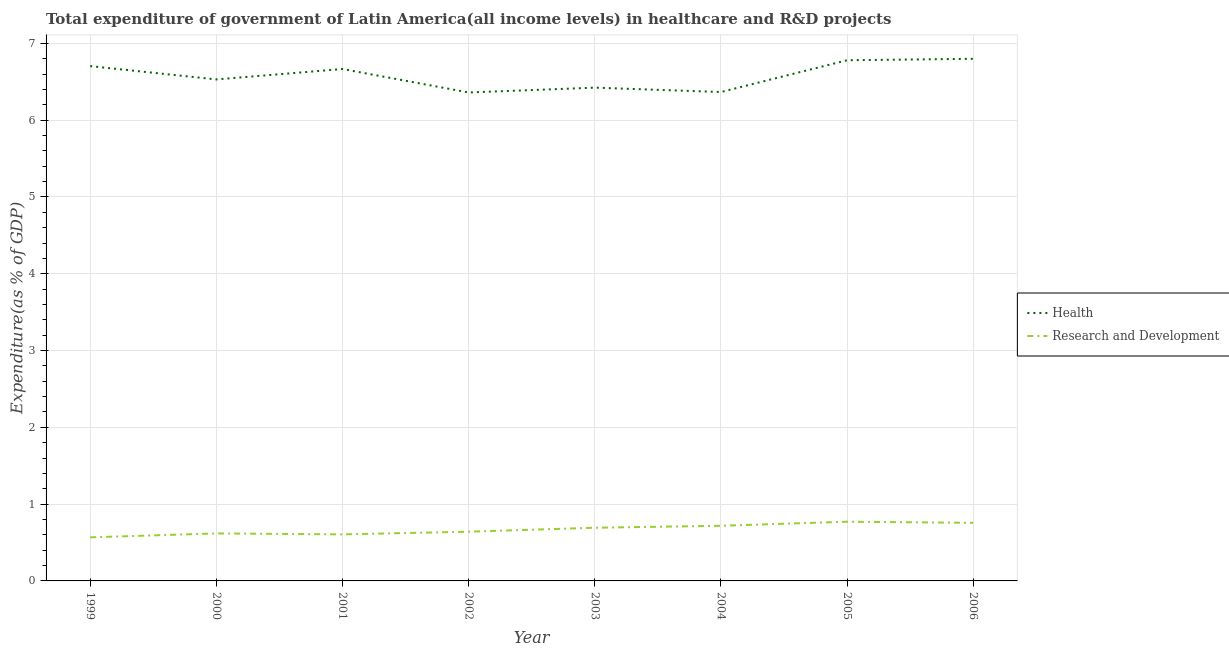What is the expenditure in r&d in 2001?
Provide a short and direct response. 0.61. Across all years, what is the maximum expenditure in r&d?
Provide a succinct answer. 0.77. Across all years, what is the minimum expenditure in healthcare?
Offer a very short reply. 6.36. In which year was the expenditure in r&d minimum?
Your answer should be very brief. 1999. What is the total expenditure in healthcare in the graph?
Your answer should be compact. 52.63. What is the difference between the expenditure in healthcare in 2000 and that in 2003?
Provide a succinct answer. 0.11. What is the difference between the expenditure in r&d in 2006 and the expenditure in healthcare in 2001?
Offer a terse response. -5.91. What is the average expenditure in r&d per year?
Your answer should be very brief. 0.67. In the year 2006, what is the difference between the expenditure in r&d and expenditure in healthcare?
Offer a terse response. -6.04. In how many years, is the expenditure in r&d greater than 0.8 %?
Keep it short and to the point. 0. What is the ratio of the expenditure in healthcare in 1999 to that in 2002?
Offer a terse response. 1.05. What is the difference between the highest and the second highest expenditure in r&d?
Your answer should be very brief. 0.01. What is the difference between the highest and the lowest expenditure in r&d?
Provide a short and direct response. 0.2. In how many years, is the expenditure in healthcare greater than the average expenditure in healthcare taken over all years?
Your response must be concise. 4. Are the values on the major ticks of Y-axis written in scientific E-notation?
Ensure brevity in your answer.  No. Does the graph contain grids?
Provide a short and direct response. Yes. How many legend labels are there?
Your answer should be very brief. 2. What is the title of the graph?
Offer a very short reply. Total expenditure of government of Latin America(all income levels) in healthcare and R&D projects. What is the label or title of the X-axis?
Offer a terse response. Year. What is the label or title of the Y-axis?
Provide a short and direct response. Expenditure(as % of GDP). What is the Expenditure(as % of GDP) in Health in 1999?
Your response must be concise. 6.7. What is the Expenditure(as % of GDP) of Research and Development in 1999?
Give a very brief answer. 0.57. What is the Expenditure(as % of GDP) of Health in 2000?
Make the answer very short. 6.53. What is the Expenditure(as % of GDP) of Research and Development in 2000?
Ensure brevity in your answer.  0.62. What is the Expenditure(as % of GDP) of Health in 2001?
Provide a short and direct response. 6.67. What is the Expenditure(as % of GDP) of Research and Development in 2001?
Your response must be concise. 0.61. What is the Expenditure(as % of GDP) of Health in 2002?
Make the answer very short. 6.36. What is the Expenditure(as % of GDP) of Research and Development in 2002?
Offer a terse response. 0.64. What is the Expenditure(as % of GDP) of Health in 2003?
Keep it short and to the point. 6.42. What is the Expenditure(as % of GDP) in Research and Development in 2003?
Your response must be concise. 0.69. What is the Expenditure(as % of GDP) in Health in 2004?
Give a very brief answer. 6.37. What is the Expenditure(as % of GDP) of Research and Development in 2004?
Provide a short and direct response. 0.72. What is the Expenditure(as % of GDP) in Health in 2005?
Ensure brevity in your answer.  6.78. What is the Expenditure(as % of GDP) of Research and Development in 2005?
Your response must be concise. 0.77. What is the Expenditure(as % of GDP) of Health in 2006?
Provide a short and direct response. 6.8. What is the Expenditure(as % of GDP) of Research and Development in 2006?
Provide a succinct answer. 0.76. Across all years, what is the maximum Expenditure(as % of GDP) in Health?
Keep it short and to the point. 6.8. Across all years, what is the maximum Expenditure(as % of GDP) in Research and Development?
Your answer should be compact. 0.77. Across all years, what is the minimum Expenditure(as % of GDP) of Health?
Give a very brief answer. 6.36. Across all years, what is the minimum Expenditure(as % of GDP) of Research and Development?
Keep it short and to the point. 0.57. What is the total Expenditure(as % of GDP) in Health in the graph?
Make the answer very short. 52.63. What is the total Expenditure(as % of GDP) in Research and Development in the graph?
Offer a very short reply. 5.37. What is the difference between the Expenditure(as % of GDP) of Health in 1999 and that in 2000?
Offer a very short reply. 0.17. What is the difference between the Expenditure(as % of GDP) of Research and Development in 1999 and that in 2000?
Your answer should be compact. -0.05. What is the difference between the Expenditure(as % of GDP) in Health in 1999 and that in 2001?
Provide a short and direct response. 0.04. What is the difference between the Expenditure(as % of GDP) in Research and Development in 1999 and that in 2001?
Your response must be concise. -0.04. What is the difference between the Expenditure(as % of GDP) in Health in 1999 and that in 2002?
Offer a terse response. 0.34. What is the difference between the Expenditure(as % of GDP) in Research and Development in 1999 and that in 2002?
Offer a terse response. -0.07. What is the difference between the Expenditure(as % of GDP) of Health in 1999 and that in 2003?
Keep it short and to the point. 0.28. What is the difference between the Expenditure(as % of GDP) in Research and Development in 1999 and that in 2003?
Your answer should be compact. -0.13. What is the difference between the Expenditure(as % of GDP) of Health in 1999 and that in 2004?
Offer a terse response. 0.34. What is the difference between the Expenditure(as % of GDP) in Research and Development in 1999 and that in 2004?
Give a very brief answer. -0.15. What is the difference between the Expenditure(as % of GDP) of Health in 1999 and that in 2005?
Your response must be concise. -0.08. What is the difference between the Expenditure(as % of GDP) in Research and Development in 1999 and that in 2005?
Offer a terse response. -0.2. What is the difference between the Expenditure(as % of GDP) in Health in 1999 and that in 2006?
Offer a terse response. -0.1. What is the difference between the Expenditure(as % of GDP) in Research and Development in 1999 and that in 2006?
Your response must be concise. -0.19. What is the difference between the Expenditure(as % of GDP) in Health in 2000 and that in 2001?
Your answer should be very brief. -0.14. What is the difference between the Expenditure(as % of GDP) of Research and Development in 2000 and that in 2001?
Your answer should be compact. 0.01. What is the difference between the Expenditure(as % of GDP) of Health in 2000 and that in 2002?
Make the answer very short. 0.17. What is the difference between the Expenditure(as % of GDP) in Research and Development in 2000 and that in 2002?
Provide a succinct answer. -0.02. What is the difference between the Expenditure(as % of GDP) of Health in 2000 and that in 2003?
Keep it short and to the point. 0.11. What is the difference between the Expenditure(as % of GDP) of Research and Development in 2000 and that in 2003?
Provide a succinct answer. -0.07. What is the difference between the Expenditure(as % of GDP) of Health in 2000 and that in 2004?
Ensure brevity in your answer.  0.16. What is the difference between the Expenditure(as % of GDP) of Research and Development in 2000 and that in 2004?
Your answer should be very brief. -0.1. What is the difference between the Expenditure(as % of GDP) of Health in 2000 and that in 2005?
Provide a short and direct response. -0.25. What is the difference between the Expenditure(as % of GDP) in Research and Development in 2000 and that in 2005?
Give a very brief answer. -0.15. What is the difference between the Expenditure(as % of GDP) of Health in 2000 and that in 2006?
Make the answer very short. -0.27. What is the difference between the Expenditure(as % of GDP) of Research and Development in 2000 and that in 2006?
Ensure brevity in your answer.  -0.14. What is the difference between the Expenditure(as % of GDP) in Health in 2001 and that in 2002?
Ensure brevity in your answer.  0.31. What is the difference between the Expenditure(as % of GDP) of Research and Development in 2001 and that in 2002?
Ensure brevity in your answer.  -0.03. What is the difference between the Expenditure(as % of GDP) of Health in 2001 and that in 2003?
Your answer should be very brief. 0.24. What is the difference between the Expenditure(as % of GDP) of Research and Development in 2001 and that in 2003?
Your response must be concise. -0.09. What is the difference between the Expenditure(as % of GDP) in Health in 2001 and that in 2004?
Make the answer very short. 0.3. What is the difference between the Expenditure(as % of GDP) of Research and Development in 2001 and that in 2004?
Offer a very short reply. -0.11. What is the difference between the Expenditure(as % of GDP) of Health in 2001 and that in 2005?
Your response must be concise. -0.11. What is the difference between the Expenditure(as % of GDP) in Research and Development in 2001 and that in 2005?
Your response must be concise. -0.16. What is the difference between the Expenditure(as % of GDP) of Health in 2001 and that in 2006?
Ensure brevity in your answer.  -0.13. What is the difference between the Expenditure(as % of GDP) in Research and Development in 2001 and that in 2006?
Make the answer very short. -0.15. What is the difference between the Expenditure(as % of GDP) in Health in 2002 and that in 2003?
Your response must be concise. -0.06. What is the difference between the Expenditure(as % of GDP) in Research and Development in 2002 and that in 2003?
Your answer should be compact. -0.05. What is the difference between the Expenditure(as % of GDP) in Health in 2002 and that in 2004?
Make the answer very short. -0.01. What is the difference between the Expenditure(as % of GDP) of Research and Development in 2002 and that in 2004?
Your answer should be compact. -0.08. What is the difference between the Expenditure(as % of GDP) of Health in 2002 and that in 2005?
Make the answer very short. -0.42. What is the difference between the Expenditure(as % of GDP) in Research and Development in 2002 and that in 2005?
Offer a terse response. -0.13. What is the difference between the Expenditure(as % of GDP) in Health in 2002 and that in 2006?
Provide a short and direct response. -0.44. What is the difference between the Expenditure(as % of GDP) in Research and Development in 2002 and that in 2006?
Your answer should be very brief. -0.12. What is the difference between the Expenditure(as % of GDP) in Health in 2003 and that in 2004?
Your answer should be very brief. 0.06. What is the difference between the Expenditure(as % of GDP) of Research and Development in 2003 and that in 2004?
Provide a short and direct response. -0.03. What is the difference between the Expenditure(as % of GDP) in Health in 2003 and that in 2005?
Make the answer very short. -0.36. What is the difference between the Expenditure(as % of GDP) in Research and Development in 2003 and that in 2005?
Provide a short and direct response. -0.08. What is the difference between the Expenditure(as % of GDP) in Health in 2003 and that in 2006?
Provide a succinct answer. -0.38. What is the difference between the Expenditure(as % of GDP) in Research and Development in 2003 and that in 2006?
Your response must be concise. -0.06. What is the difference between the Expenditure(as % of GDP) of Health in 2004 and that in 2005?
Offer a very short reply. -0.41. What is the difference between the Expenditure(as % of GDP) of Research and Development in 2004 and that in 2005?
Your response must be concise. -0.05. What is the difference between the Expenditure(as % of GDP) of Health in 2004 and that in 2006?
Provide a succinct answer. -0.43. What is the difference between the Expenditure(as % of GDP) in Research and Development in 2004 and that in 2006?
Ensure brevity in your answer.  -0.04. What is the difference between the Expenditure(as % of GDP) of Health in 2005 and that in 2006?
Provide a succinct answer. -0.02. What is the difference between the Expenditure(as % of GDP) in Research and Development in 2005 and that in 2006?
Your answer should be compact. 0.01. What is the difference between the Expenditure(as % of GDP) of Health in 1999 and the Expenditure(as % of GDP) of Research and Development in 2000?
Provide a succinct answer. 6.08. What is the difference between the Expenditure(as % of GDP) of Health in 1999 and the Expenditure(as % of GDP) of Research and Development in 2001?
Your answer should be very brief. 6.1. What is the difference between the Expenditure(as % of GDP) of Health in 1999 and the Expenditure(as % of GDP) of Research and Development in 2002?
Provide a succinct answer. 6.06. What is the difference between the Expenditure(as % of GDP) in Health in 1999 and the Expenditure(as % of GDP) in Research and Development in 2003?
Ensure brevity in your answer.  6.01. What is the difference between the Expenditure(as % of GDP) in Health in 1999 and the Expenditure(as % of GDP) in Research and Development in 2004?
Keep it short and to the point. 5.99. What is the difference between the Expenditure(as % of GDP) of Health in 1999 and the Expenditure(as % of GDP) of Research and Development in 2005?
Offer a terse response. 5.93. What is the difference between the Expenditure(as % of GDP) in Health in 1999 and the Expenditure(as % of GDP) in Research and Development in 2006?
Keep it short and to the point. 5.95. What is the difference between the Expenditure(as % of GDP) in Health in 2000 and the Expenditure(as % of GDP) in Research and Development in 2001?
Your answer should be compact. 5.92. What is the difference between the Expenditure(as % of GDP) of Health in 2000 and the Expenditure(as % of GDP) of Research and Development in 2002?
Provide a succinct answer. 5.89. What is the difference between the Expenditure(as % of GDP) of Health in 2000 and the Expenditure(as % of GDP) of Research and Development in 2003?
Keep it short and to the point. 5.84. What is the difference between the Expenditure(as % of GDP) of Health in 2000 and the Expenditure(as % of GDP) of Research and Development in 2004?
Your answer should be very brief. 5.81. What is the difference between the Expenditure(as % of GDP) of Health in 2000 and the Expenditure(as % of GDP) of Research and Development in 2005?
Offer a very short reply. 5.76. What is the difference between the Expenditure(as % of GDP) in Health in 2000 and the Expenditure(as % of GDP) in Research and Development in 2006?
Your answer should be very brief. 5.77. What is the difference between the Expenditure(as % of GDP) in Health in 2001 and the Expenditure(as % of GDP) in Research and Development in 2002?
Your answer should be very brief. 6.03. What is the difference between the Expenditure(as % of GDP) in Health in 2001 and the Expenditure(as % of GDP) in Research and Development in 2003?
Offer a terse response. 5.97. What is the difference between the Expenditure(as % of GDP) of Health in 2001 and the Expenditure(as % of GDP) of Research and Development in 2004?
Your answer should be compact. 5.95. What is the difference between the Expenditure(as % of GDP) in Health in 2001 and the Expenditure(as % of GDP) in Research and Development in 2005?
Provide a short and direct response. 5.89. What is the difference between the Expenditure(as % of GDP) in Health in 2001 and the Expenditure(as % of GDP) in Research and Development in 2006?
Offer a very short reply. 5.91. What is the difference between the Expenditure(as % of GDP) in Health in 2002 and the Expenditure(as % of GDP) in Research and Development in 2003?
Offer a very short reply. 5.67. What is the difference between the Expenditure(as % of GDP) in Health in 2002 and the Expenditure(as % of GDP) in Research and Development in 2004?
Ensure brevity in your answer.  5.64. What is the difference between the Expenditure(as % of GDP) of Health in 2002 and the Expenditure(as % of GDP) of Research and Development in 2005?
Provide a succinct answer. 5.59. What is the difference between the Expenditure(as % of GDP) in Health in 2002 and the Expenditure(as % of GDP) in Research and Development in 2006?
Give a very brief answer. 5.6. What is the difference between the Expenditure(as % of GDP) in Health in 2003 and the Expenditure(as % of GDP) in Research and Development in 2004?
Offer a terse response. 5.71. What is the difference between the Expenditure(as % of GDP) of Health in 2003 and the Expenditure(as % of GDP) of Research and Development in 2005?
Your answer should be very brief. 5.65. What is the difference between the Expenditure(as % of GDP) in Health in 2003 and the Expenditure(as % of GDP) in Research and Development in 2006?
Offer a terse response. 5.67. What is the difference between the Expenditure(as % of GDP) in Health in 2004 and the Expenditure(as % of GDP) in Research and Development in 2005?
Provide a short and direct response. 5.6. What is the difference between the Expenditure(as % of GDP) in Health in 2004 and the Expenditure(as % of GDP) in Research and Development in 2006?
Give a very brief answer. 5.61. What is the difference between the Expenditure(as % of GDP) in Health in 2005 and the Expenditure(as % of GDP) in Research and Development in 2006?
Give a very brief answer. 6.02. What is the average Expenditure(as % of GDP) of Health per year?
Make the answer very short. 6.58. What is the average Expenditure(as % of GDP) of Research and Development per year?
Provide a short and direct response. 0.67. In the year 1999, what is the difference between the Expenditure(as % of GDP) in Health and Expenditure(as % of GDP) in Research and Development?
Give a very brief answer. 6.14. In the year 2000, what is the difference between the Expenditure(as % of GDP) of Health and Expenditure(as % of GDP) of Research and Development?
Make the answer very short. 5.91. In the year 2001, what is the difference between the Expenditure(as % of GDP) of Health and Expenditure(as % of GDP) of Research and Development?
Keep it short and to the point. 6.06. In the year 2002, what is the difference between the Expenditure(as % of GDP) in Health and Expenditure(as % of GDP) in Research and Development?
Ensure brevity in your answer.  5.72. In the year 2003, what is the difference between the Expenditure(as % of GDP) of Health and Expenditure(as % of GDP) of Research and Development?
Your response must be concise. 5.73. In the year 2004, what is the difference between the Expenditure(as % of GDP) of Health and Expenditure(as % of GDP) of Research and Development?
Ensure brevity in your answer.  5.65. In the year 2005, what is the difference between the Expenditure(as % of GDP) of Health and Expenditure(as % of GDP) of Research and Development?
Give a very brief answer. 6.01. In the year 2006, what is the difference between the Expenditure(as % of GDP) in Health and Expenditure(as % of GDP) in Research and Development?
Your answer should be very brief. 6.04. What is the ratio of the Expenditure(as % of GDP) in Health in 1999 to that in 2000?
Make the answer very short. 1.03. What is the ratio of the Expenditure(as % of GDP) in Research and Development in 1999 to that in 2000?
Your answer should be compact. 0.92. What is the ratio of the Expenditure(as % of GDP) of Research and Development in 1999 to that in 2001?
Provide a short and direct response. 0.94. What is the ratio of the Expenditure(as % of GDP) of Health in 1999 to that in 2002?
Provide a short and direct response. 1.05. What is the ratio of the Expenditure(as % of GDP) in Research and Development in 1999 to that in 2002?
Your response must be concise. 0.89. What is the ratio of the Expenditure(as % of GDP) in Health in 1999 to that in 2003?
Offer a very short reply. 1.04. What is the ratio of the Expenditure(as % of GDP) of Research and Development in 1999 to that in 2003?
Ensure brevity in your answer.  0.82. What is the ratio of the Expenditure(as % of GDP) in Health in 1999 to that in 2004?
Offer a terse response. 1.05. What is the ratio of the Expenditure(as % of GDP) of Research and Development in 1999 to that in 2004?
Offer a terse response. 0.79. What is the ratio of the Expenditure(as % of GDP) in Health in 1999 to that in 2005?
Your answer should be very brief. 0.99. What is the ratio of the Expenditure(as % of GDP) in Research and Development in 1999 to that in 2005?
Keep it short and to the point. 0.74. What is the ratio of the Expenditure(as % of GDP) of Health in 1999 to that in 2006?
Give a very brief answer. 0.99. What is the ratio of the Expenditure(as % of GDP) in Research and Development in 1999 to that in 2006?
Offer a terse response. 0.75. What is the ratio of the Expenditure(as % of GDP) in Health in 2000 to that in 2001?
Provide a short and direct response. 0.98. What is the ratio of the Expenditure(as % of GDP) in Research and Development in 2000 to that in 2001?
Give a very brief answer. 1.02. What is the ratio of the Expenditure(as % of GDP) of Health in 2000 to that in 2002?
Your answer should be very brief. 1.03. What is the ratio of the Expenditure(as % of GDP) of Research and Development in 2000 to that in 2002?
Offer a very short reply. 0.97. What is the ratio of the Expenditure(as % of GDP) in Health in 2000 to that in 2003?
Give a very brief answer. 1.02. What is the ratio of the Expenditure(as % of GDP) of Research and Development in 2000 to that in 2003?
Your answer should be very brief. 0.89. What is the ratio of the Expenditure(as % of GDP) in Health in 2000 to that in 2004?
Make the answer very short. 1.03. What is the ratio of the Expenditure(as % of GDP) in Research and Development in 2000 to that in 2004?
Your answer should be compact. 0.86. What is the ratio of the Expenditure(as % of GDP) in Health in 2000 to that in 2005?
Provide a short and direct response. 0.96. What is the ratio of the Expenditure(as % of GDP) in Research and Development in 2000 to that in 2005?
Make the answer very short. 0.8. What is the ratio of the Expenditure(as % of GDP) of Health in 2000 to that in 2006?
Your answer should be very brief. 0.96. What is the ratio of the Expenditure(as % of GDP) of Research and Development in 2000 to that in 2006?
Provide a succinct answer. 0.82. What is the ratio of the Expenditure(as % of GDP) in Health in 2001 to that in 2002?
Your answer should be very brief. 1.05. What is the ratio of the Expenditure(as % of GDP) of Research and Development in 2001 to that in 2002?
Keep it short and to the point. 0.95. What is the ratio of the Expenditure(as % of GDP) of Health in 2001 to that in 2003?
Your answer should be very brief. 1.04. What is the ratio of the Expenditure(as % of GDP) of Research and Development in 2001 to that in 2003?
Keep it short and to the point. 0.88. What is the ratio of the Expenditure(as % of GDP) in Health in 2001 to that in 2004?
Provide a succinct answer. 1.05. What is the ratio of the Expenditure(as % of GDP) of Research and Development in 2001 to that in 2004?
Your response must be concise. 0.84. What is the ratio of the Expenditure(as % of GDP) of Health in 2001 to that in 2005?
Provide a short and direct response. 0.98. What is the ratio of the Expenditure(as % of GDP) of Research and Development in 2001 to that in 2005?
Offer a terse response. 0.79. What is the ratio of the Expenditure(as % of GDP) in Health in 2001 to that in 2006?
Your response must be concise. 0.98. What is the ratio of the Expenditure(as % of GDP) of Research and Development in 2001 to that in 2006?
Make the answer very short. 0.8. What is the ratio of the Expenditure(as % of GDP) in Health in 2002 to that in 2003?
Ensure brevity in your answer.  0.99. What is the ratio of the Expenditure(as % of GDP) of Research and Development in 2002 to that in 2003?
Make the answer very short. 0.93. What is the ratio of the Expenditure(as % of GDP) in Research and Development in 2002 to that in 2004?
Keep it short and to the point. 0.89. What is the ratio of the Expenditure(as % of GDP) of Health in 2002 to that in 2005?
Offer a very short reply. 0.94. What is the ratio of the Expenditure(as % of GDP) of Research and Development in 2002 to that in 2005?
Offer a very short reply. 0.83. What is the ratio of the Expenditure(as % of GDP) of Health in 2002 to that in 2006?
Your answer should be compact. 0.94. What is the ratio of the Expenditure(as % of GDP) of Research and Development in 2002 to that in 2006?
Your answer should be compact. 0.85. What is the ratio of the Expenditure(as % of GDP) in Health in 2003 to that in 2004?
Your answer should be compact. 1.01. What is the ratio of the Expenditure(as % of GDP) of Research and Development in 2003 to that in 2004?
Offer a terse response. 0.96. What is the ratio of the Expenditure(as % of GDP) of Research and Development in 2003 to that in 2005?
Ensure brevity in your answer.  0.9. What is the ratio of the Expenditure(as % of GDP) of Health in 2003 to that in 2006?
Your response must be concise. 0.94. What is the ratio of the Expenditure(as % of GDP) of Research and Development in 2003 to that in 2006?
Your response must be concise. 0.92. What is the ratio of the Expenditure(as % of GDP) of Health in 2004 to that in 2005?
Your answer should be compact. 0.94. What is the ratio of the Expenditure(as % of GDP) in Research and Development in 2004 to that in 2005?
Ensure brevity in your answer.  0.93. What is the ratio of the Expenditure(as % of GDP) of Health in 2004 to that in 2006?
Offer a very short reply. 0.94. What is the ratio of the Expenditure(as % of GDP) of Research and Development in 2004 to that in 2006?
Your answer should be compact. 0.95. What is the ratio of the Expenditure(as % of GDP) of Health in 2005 to that in 2006?
Make the answer very short. 1. What is the ratio of the Expenditure(as % of GDP) of Research and Development in 2005 to that in 2006?
Keep it short and to the point. 1.02. What is the difference between the highest and the second highest Expenditure(as % of GDP) in Health?
Offer a terse response. 0.02. What is the difference between the highest and the second highest Expenditure(as % of GDP) of Research and Development?
Make the answer very short. 0.01. What is the difference between the highest and the lowest Expenditure(as % of GDP) of Health?
Your response must be concise. 0.44. What is the difference between the highest and the lowest Expenditure(as % of GDP) in Research and Development?
Provide a succinct answer. 0.2. 